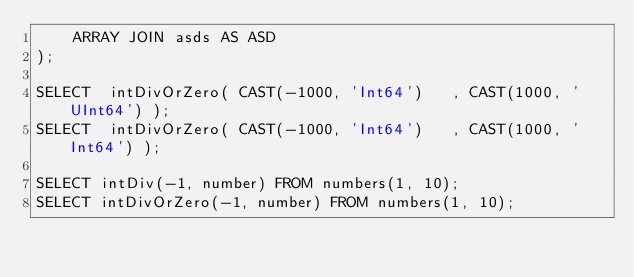<code> <loc_0><loc_0><loc_500><loc_500><_SQL_>    ARRAY JOIN asds AS ASD
);

SELECT  intDivOrZero( CAST(-1000, 'Int64')   , CAST(1000, 'UInt64') );
SELECT  intDivOrZero( CAST(-1000, 'Int64')   , CAST(1000, 'Int64') );

SELECT intDiv(-1, number) FROM numbers(1, 10);
SELECT intDivOrZero(-1, number) FROM numbers(1, 10);
</code> 